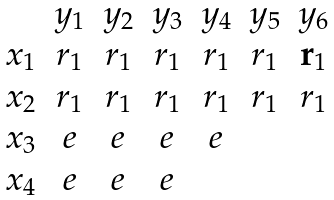<formula> <loc_0><loc_0><loc_500><loc_500>\begin{matrix} & y _ { 1 } & y _ { 2 } & y _ { 3 } & y _ { 4 } & y _ { 5 } & y _ { 6 } \\ x _ { 1 } & r _ { 1 } & r _ { 1 } & r _ { 1 } & r _ { 1 } & r _ { 1 } & { \mathbf r _ { 1 } } \\ x _ { 2 } & r _ { 1 } & r _ { 1 } & r _ { 1 } & r _ { 1 } & r _ { 1 } & r _ { 1 } \\ x _ { 3 } & e & e & e & e & \\ x _ { 4 } & e & e & e & & \\ \end{matrix}</formula> 